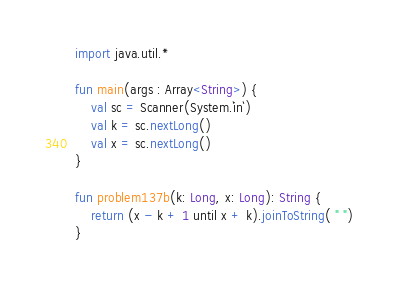<code> <loc_0><loc_0><loc_500><loc_500><_Kotlin_>import java.util.*

fun main(args : Array<String>) {
    val sc = Scanner(System.`in`)
    val k = sc.nextLong()
    val x = sc.nextLong()
}

fun problem137b(k: Long, x: Long): String {
    return (x - k + 1 until x + k).joinToString( " ")
}</code> 